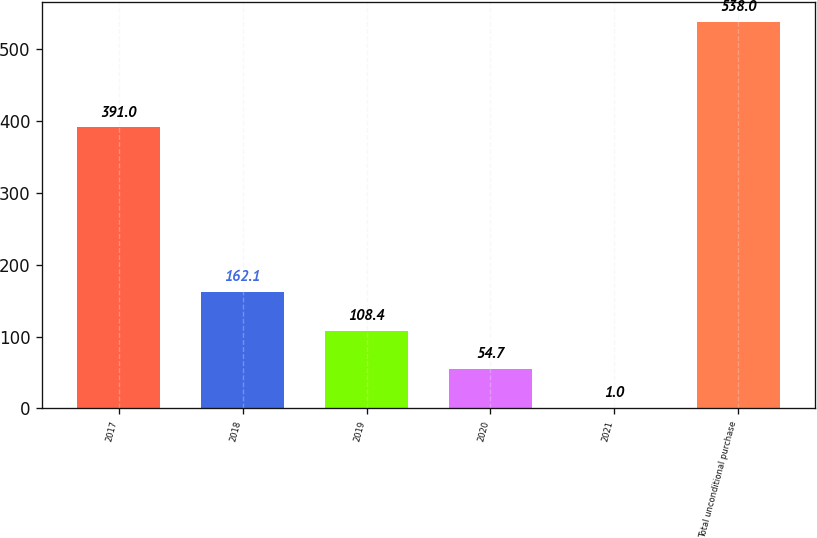Convert chart. <chart><loc_0><loc_0><loc_500><loc_500><bar_chart><fcel>2017<fcel>2018<fcel>2019<fcel>2020<fcel>2021<fcel>Total unconditional purchase<nl><fcel>391<fcel>162.1<fcel>108.4<fcel>54.7<fcel>1<fcel>538<nl></chart> 